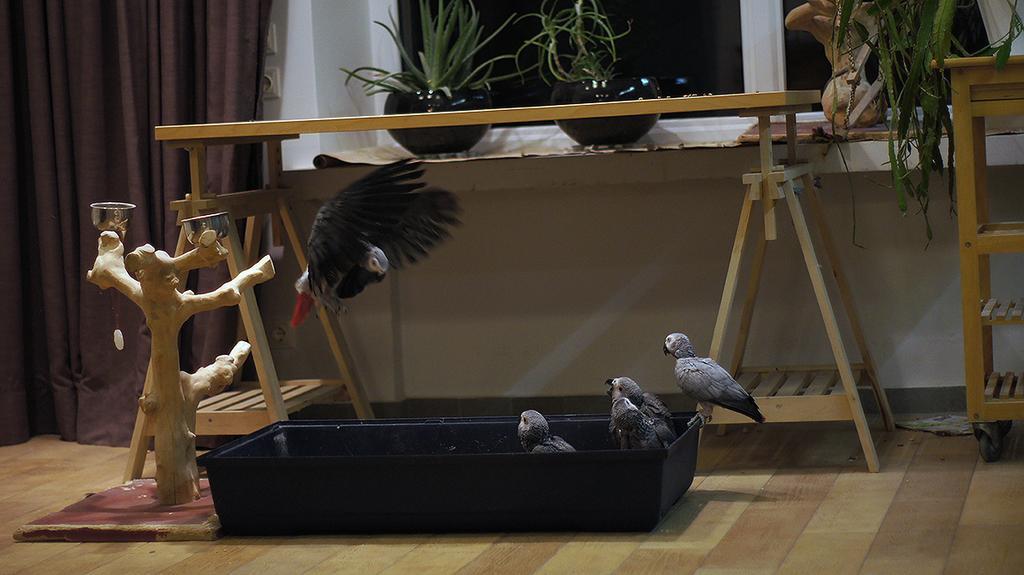In one or two sentences, can you explain what this image depicts? In this image I can see depiction of a tree trunk, few bowls, a black colour thing, few birds, tables, plants and over there I can see brown colour curtain. 